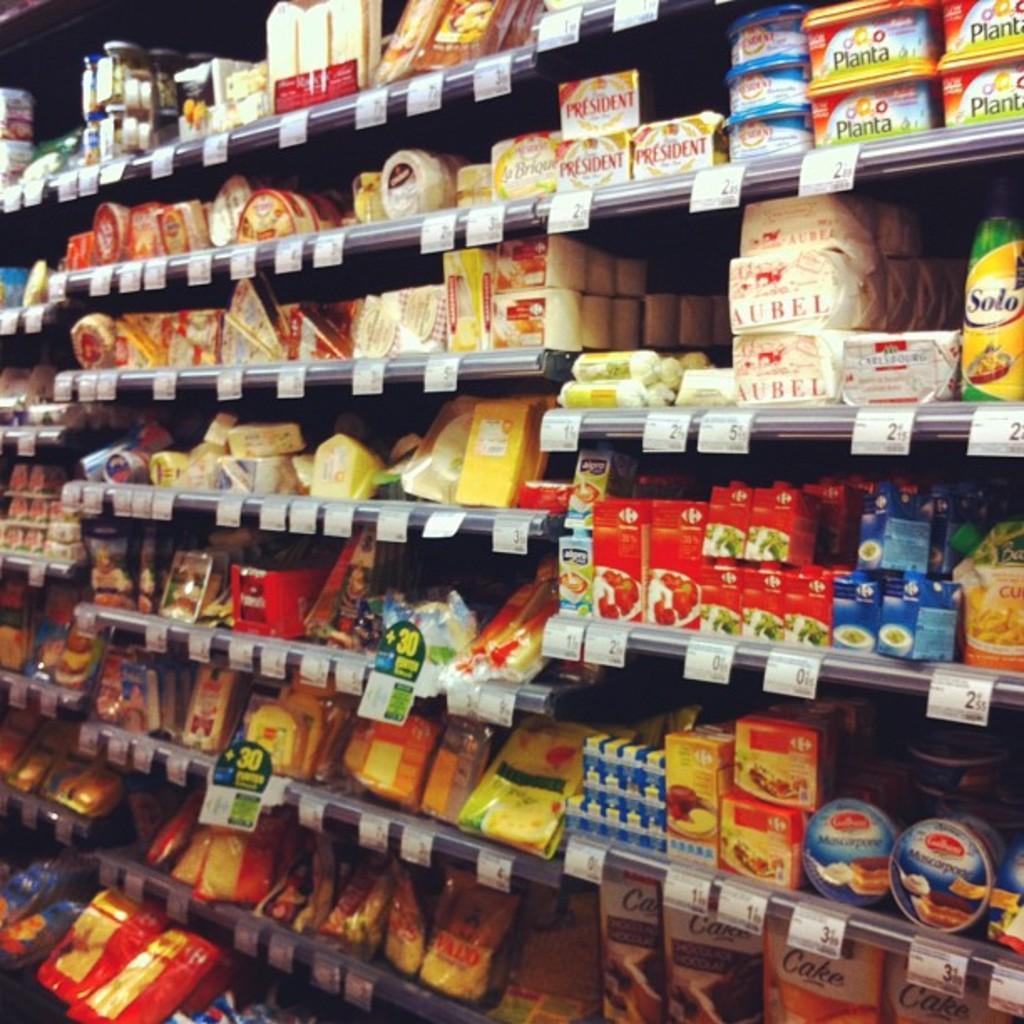What is in the tall green and yellow container on the right?
Your answer should be compact. Solo. 